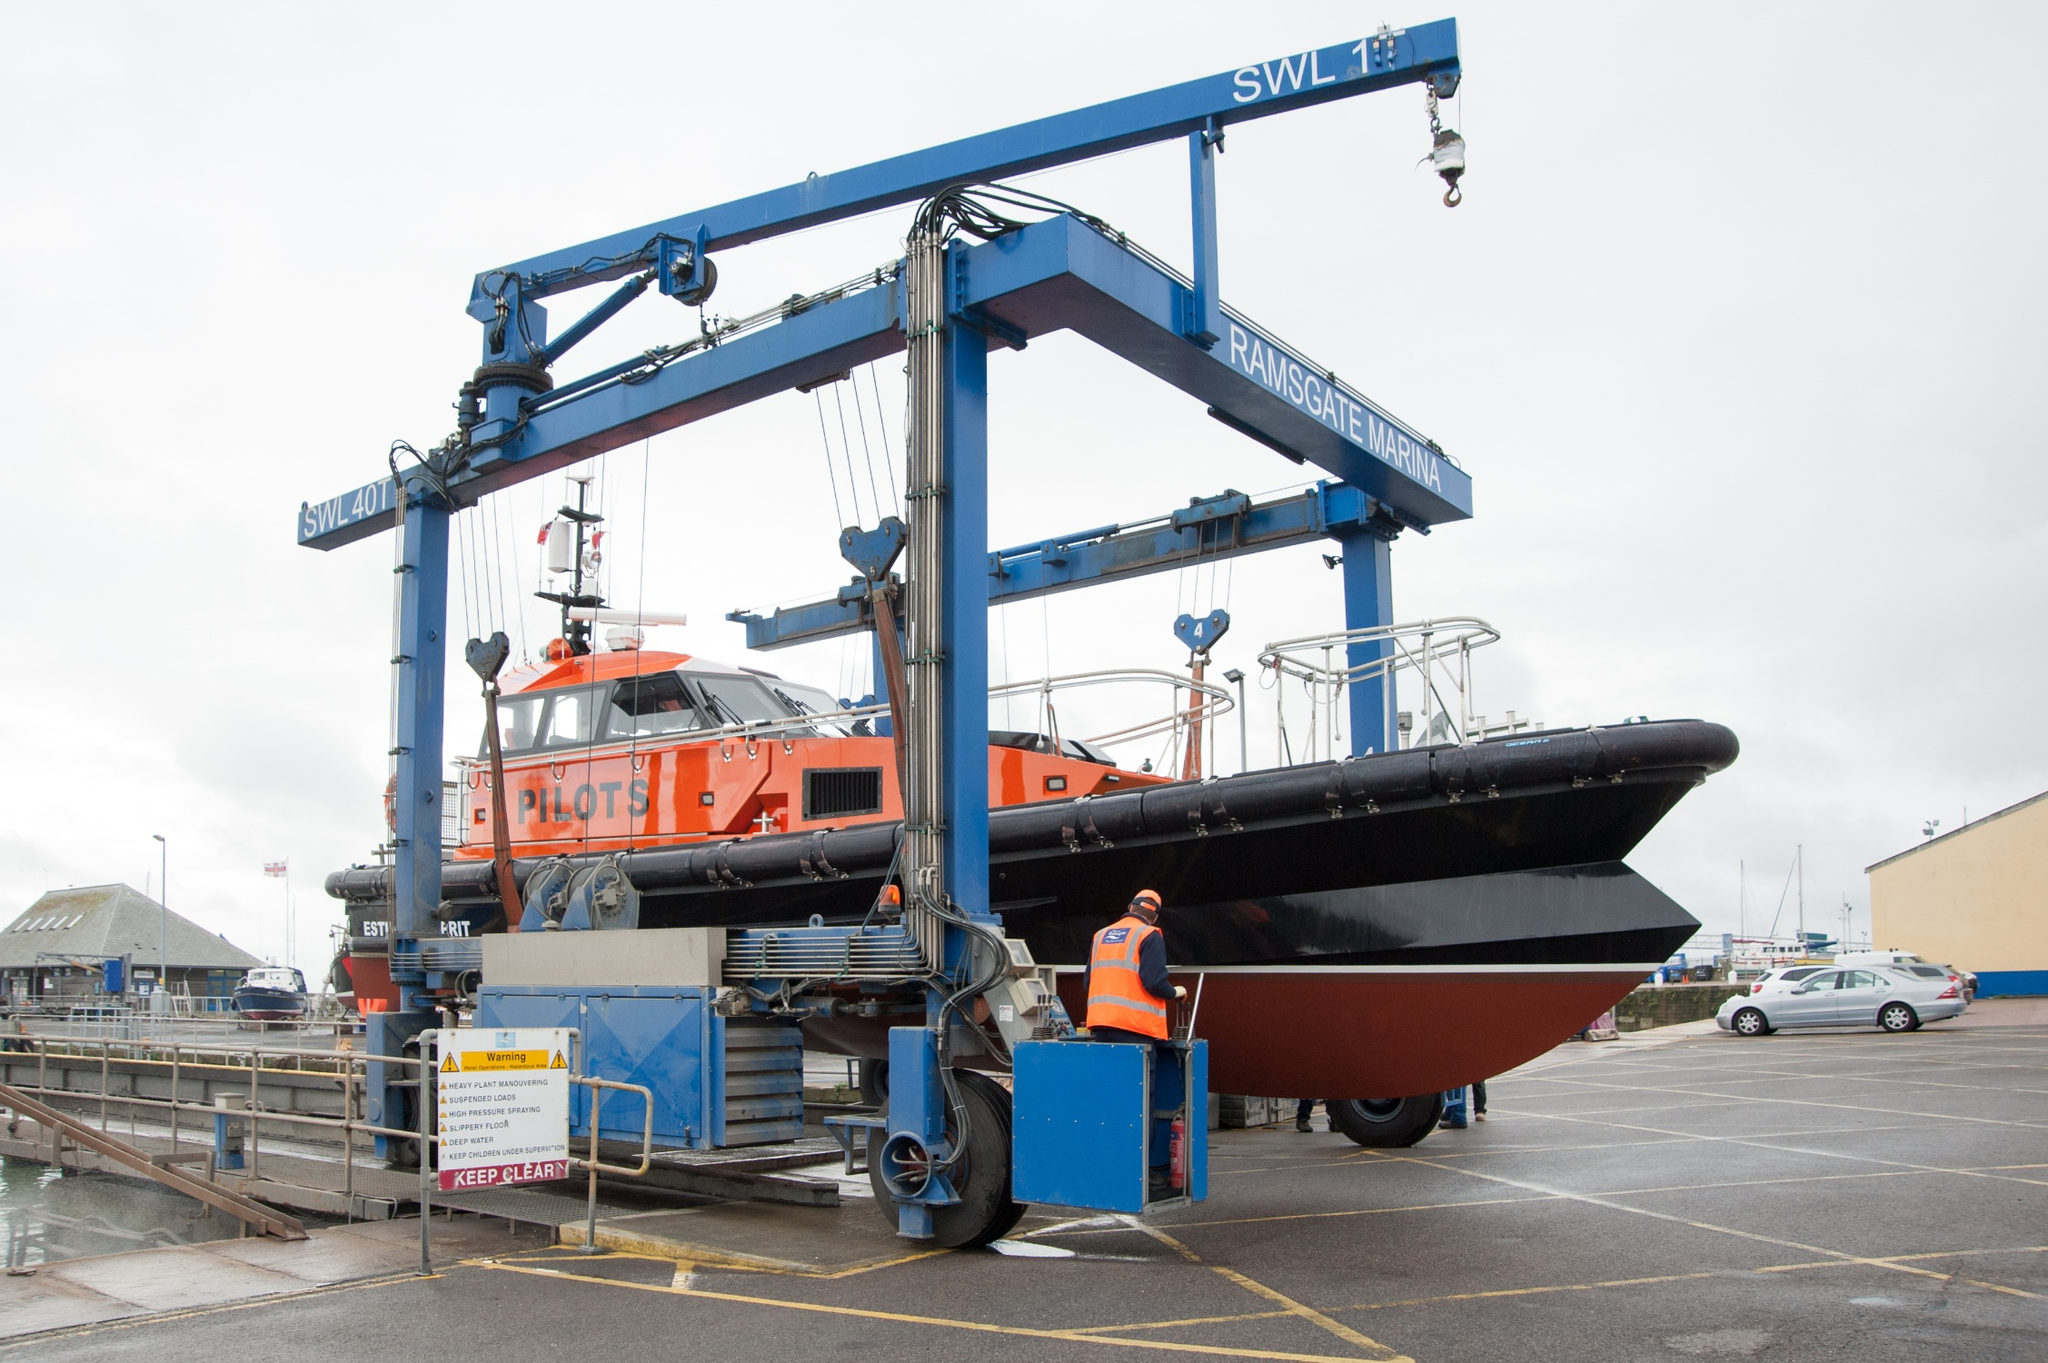What are the key elements in this picture? The image showcases a vibrant and operational scene at a marina, dominated by a large, striking blue crane labeled 'Ransomes & Rapier' with 'SWL 7t' indicating its safe working load. The crane is engaged in lifting a pilot boat, vivid in orange and black, with 'PILOTS' emblazoned across its hull. This boat is suspended in the air, supported by several cables linked to the crane. In the background, elements like a few cars and assorted buildings provide context, situating this activity within a bustling marina environment, possibly in a region similar to Ramsgate Marina, as suggested by the signage on the crane. The contrast between the vivid orange of the boat and the deep blue of the crane adds a dynamic visual interest to the scene, while the worker in orange attire near the crane's base gives a human element to the mechanical operation. 